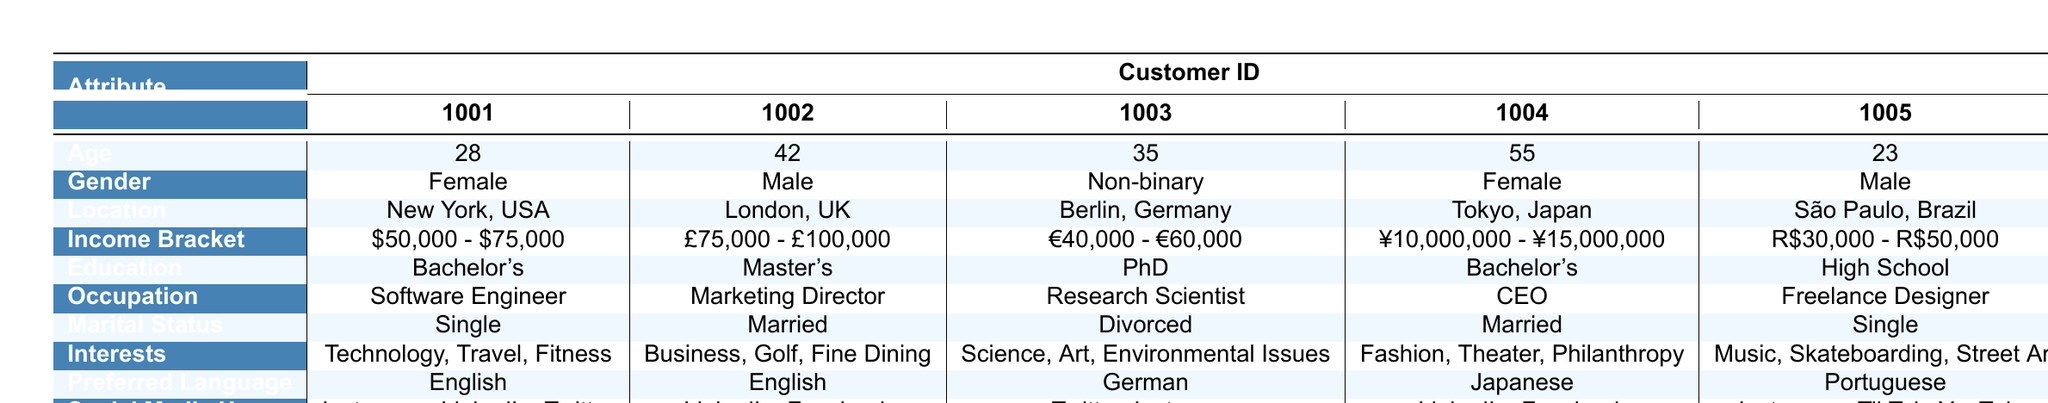What is the average age of the customers? The ages of the customers are 28, 42, 35, 55, and 23. To find the average, we sum these values: 28 + 42 + 35 + 55 + 23 = 183. Then, we divide by the number of customers, which is 5: 183/5 = 36.6.
Answer: 36.6 How many customers are single? Looking at the marital status of each customer, customer 1001 and customer 1005 are both single. This gives us a total of 2 single customers.
Answer: 2 What income bracket does customer 1004 belong to? Referring to customer 1004 in the table, their income bracket is listed as ¥10,000,000 - ¥15,000,000.
Answer: ¥10,000,000 - ¥15,000,000 Is customer 1003 interested in science? Customer 1003’s interests include science, as explicitly stated in the interests column. Therefore, the answer is yes.
Answer: Yes Which customer has the highest income bracket? Comparing income brackets, customer 1004’s income bracket (¥10,000,000 - ¥15,000,000) includes the highest range compared to the others. This is determined by evaluating the currency and its equivalent value analysis.
Answer: Customer 1004 What is the total number of unique social media platforms used by customers? The social media usage lists for customers are: customer 1001 uses 3 platforms, customer 1002 uses 2, customer 1003 uses 2, customer 1004 uses 2, and customer 1005 uses 3. Combining these, we have Instagram, LinkedIn, Twitter, Facebook, TikTok, and YouTube indicating a total of 6 unique platforms.
Answer: 6 Which customer lives in London? By reviewing the location of each customer, customer 1002 is the one listed as living in London, UK.
Answer: Customer 1002 What is the preferred language of customer 1005? Looking at customer 1005’s data in the table, their preferred language is Portuguese.
Answer: Portuguese How many interests does customer 1002 have? Customer 1002’s interests are: Business, Golf, and Fine Dining, which totals 3 interests.
Answer: 3 What percentage of the customers have a Bachelor's degree? There are 2 customers (1001 and 1004) with a Bachelor's degree out of 5 total customers. The percentage is calculated as (2/5) * 100 = 40%.
Answer: 40% 